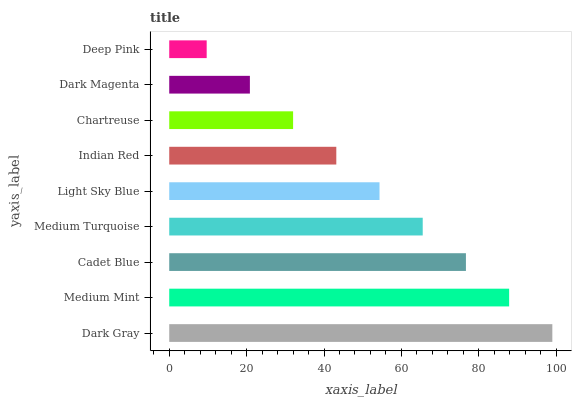Is Deep Pink the minimum?
Answer yes or no. Yes. Is Dark Gray the maximum?
Answer yes or no. Yes. Is Medium Mint the minimum?
Answer yes or no. No. Is Medium Mint the maximum?
Answer yes or no. No. Is Dark Gray greater than Medium Mint?
Answer yes or no. Yes. Is Medium Mint less than Dark Gray?
Answer yes or no. Yes. Is Medium Mint greater than Dark Gray?
Answer yes or no. No. Is Dark Gray less than Medium Mint?
Answer yes or no. No. Is Light Sky Blue the high median?
Answer yes or no. Yes. Is Light Sky Blue the low median?
Answer yes or no. Yes. Is Dark Magenta the high median?
Answer yes or no. No. Is Chartreuse the low median?
Answer yes or no. No. 